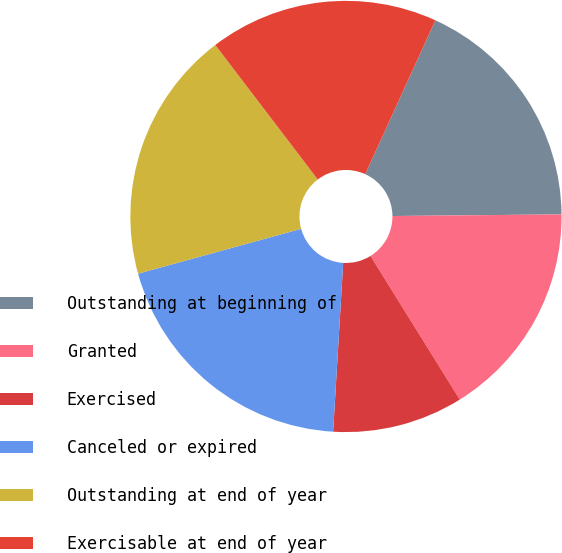Convert chart to OTSL. <chart><loc_0><loc_0><loc_500><loc_500><pie_chart><fcel>Outstanding at beginning of<fcel>Granted<fcel>Exercised<fcel>Canceled or expired<fcel>Outstanding at end of year<fcel>Exercisable at end of year<nl><fcel>18.04%<fcel>16.3%<fcel>9.8%<fcel>19.78%<fcel>18.91%<fcel>17.17%<nl></chart> 